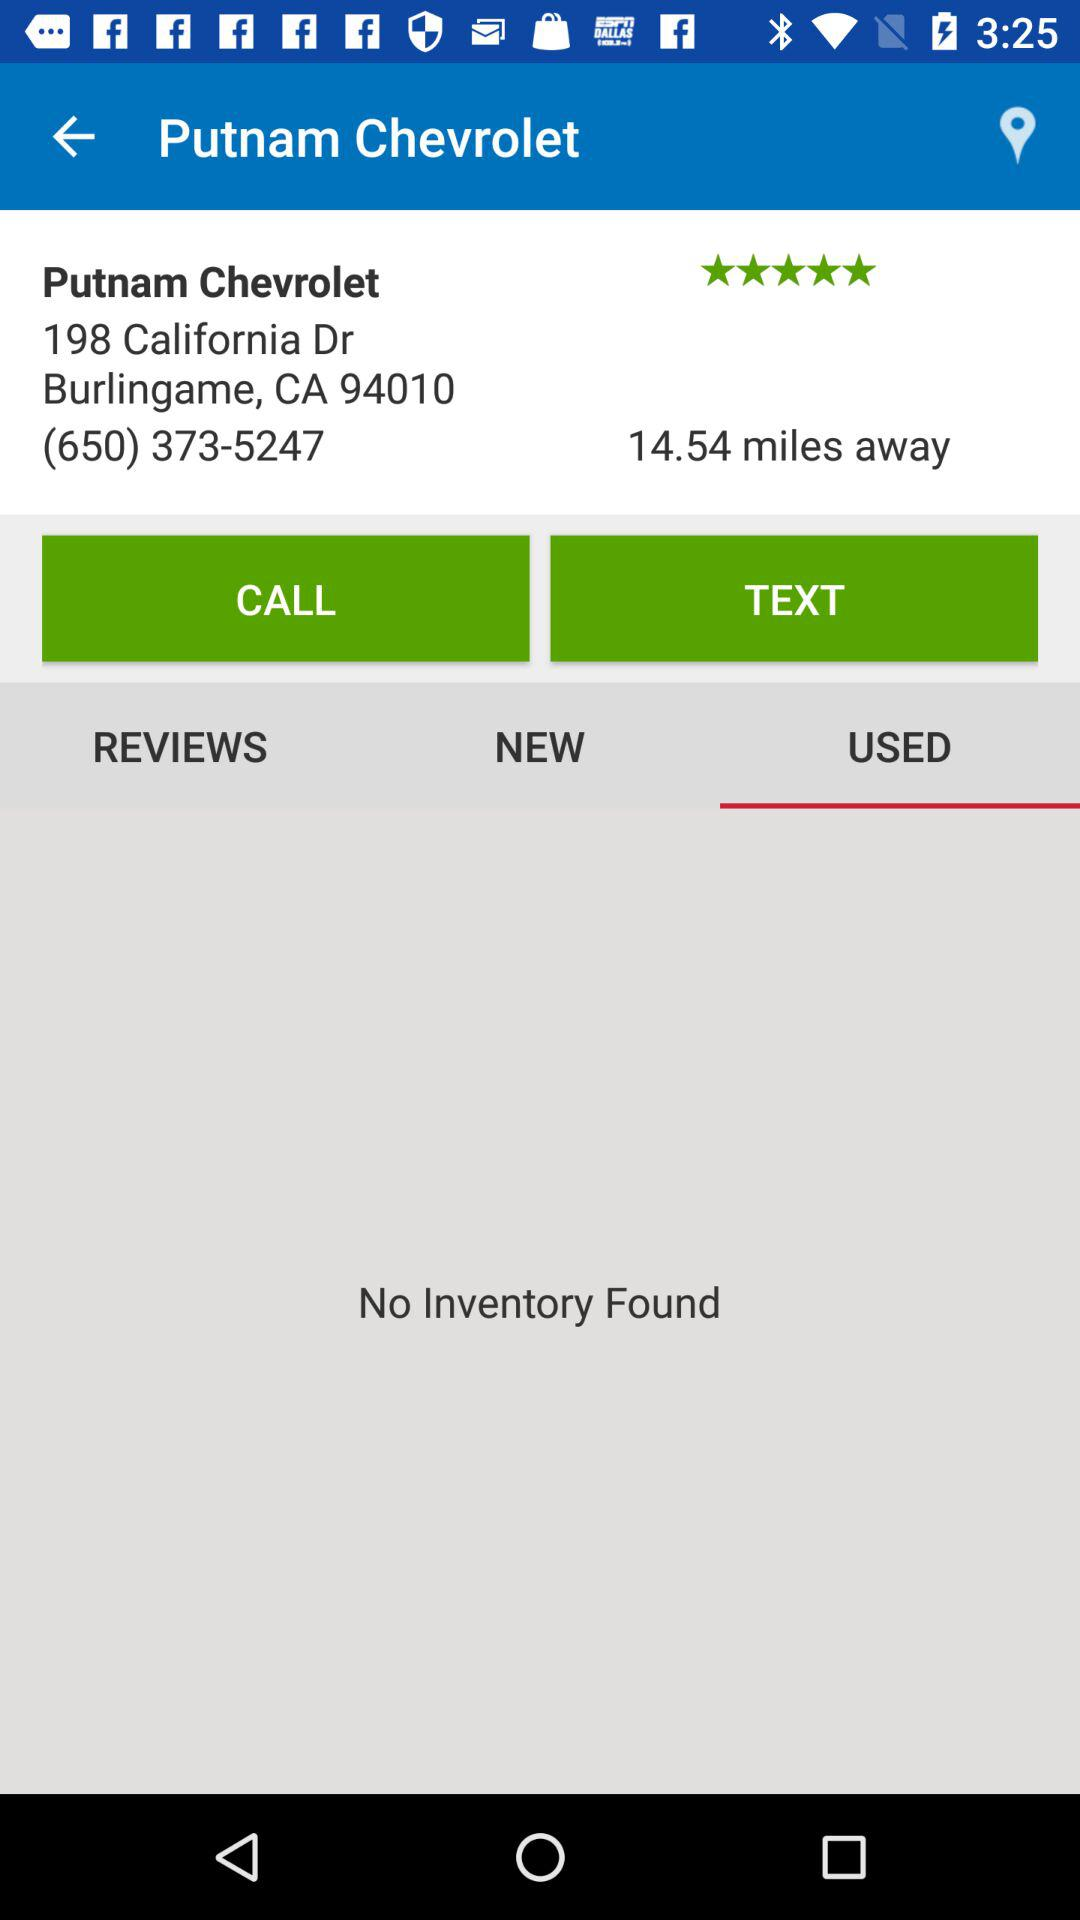How many stars did "Putnam Chevrolet" get? "Putnam Chevrolet" got 5 stars. 